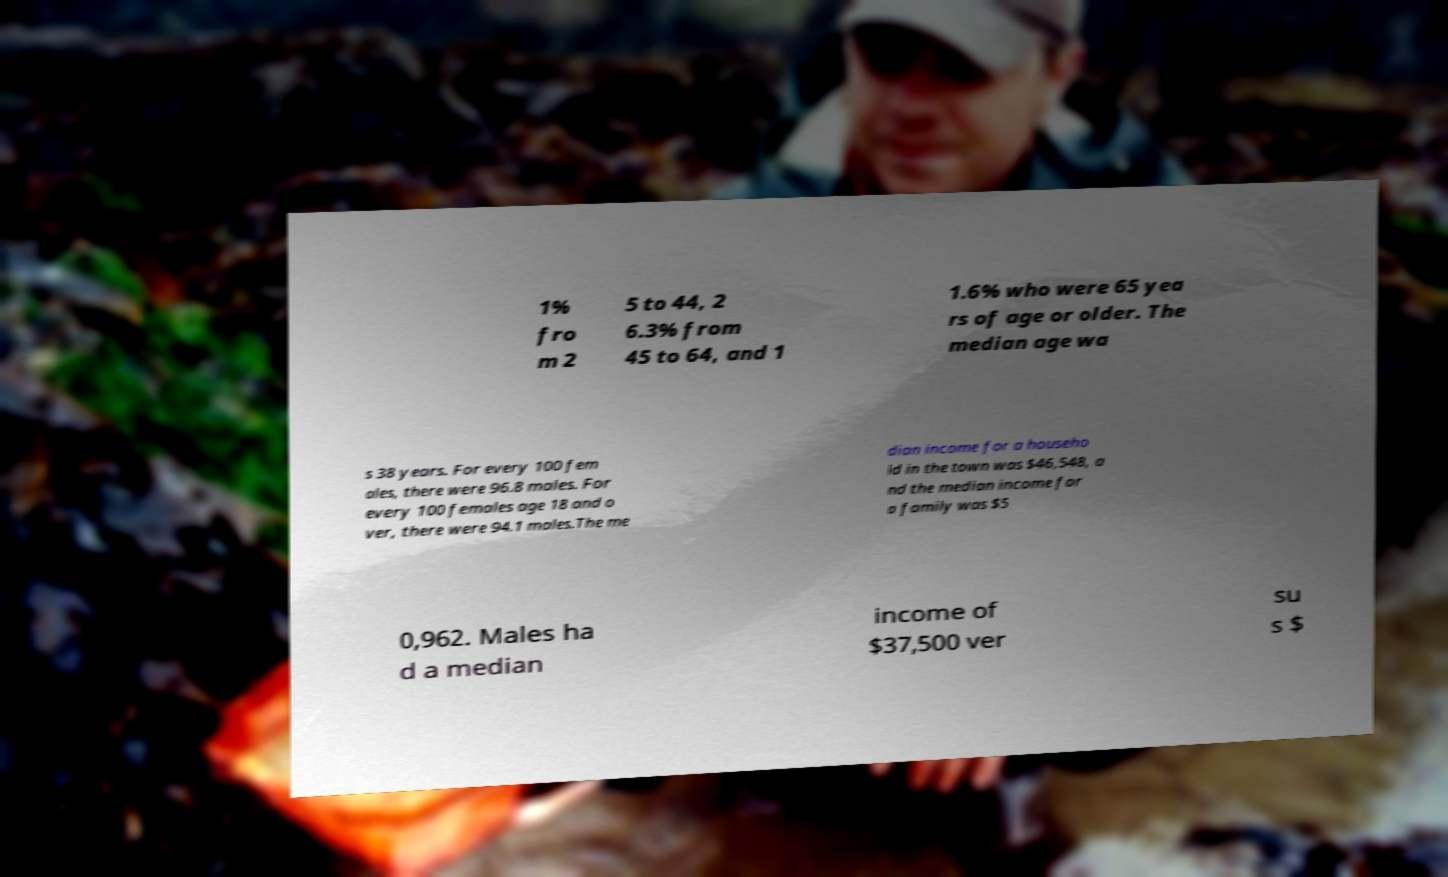Can you accurately transcribe the text from the provided image for me? 1% fro m 2 5 to 44, 2 6.3% from 45 to 64, and 1 1.6% who were 65 yea rs of age or older. The median age wa s 38 years. For every 100 fem ales, there were 96.8 males. For every 100 females age 18 and o ver, there were 94.1 males.The me dian income for a househo ld in the town was $46,548, a nd the median income for a family was $5 0,962. Males ha d a median income of $37,500 ver su s $ 